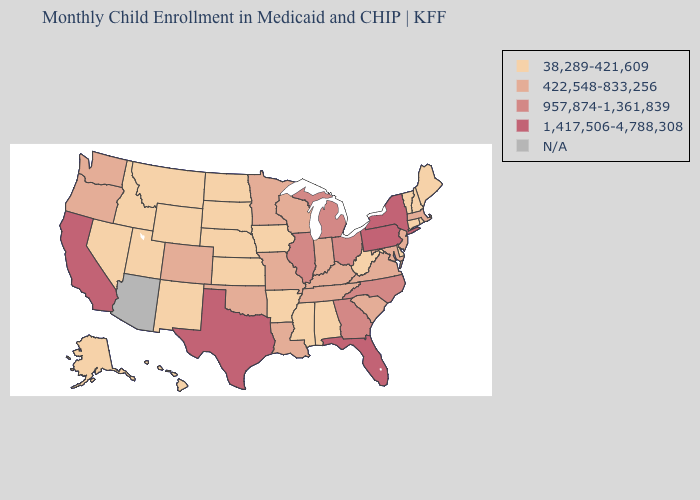Does the first symbol in the legend represent the smallest category?
Answer briefly. Yes. What is the lowest value in states that border Alabama?
Be succinct. 38,289-421,609. Which states have the lowest value in the South?
Concise answer only. Alabama, Arkansas, Delaware, Mississippi, West Virginia. Name the states that have a value in the range 422,548-833,256?
Be succinct. Colorado, Indiana, Kentucky, Louisiana, Maryland, Massachusetts, Minnesota, Missouri, New Jersey, Oklahoma, Oregon, South Carolina, Tennessee, Virginia, Washington, Wisconsin. Name the states that have a value in the range 1,417,506-4,788,308?
Concise answer only. California, Florida, New York, Pennsylvania, Texas. Does the first symbol in the legend represent the smallest category?
Concise answer only. Yes. Does California have the highest value in the USA?
Concise answer only. Yes. What is the value of Vermont?
Concise answer only. 38,289-421,609. What is the value of Vermont?
Write a very short answer. 38,289-421,609. Does California have the lowest value in the USA?
Answer briefly. No. Which states hav the highest value in the Northeast?
Keep it brief. New York, Pennsylvania. Does the first symbol in the legend represent the smallest category?
Keep it brief. Yes. What is the value of Pennsylvania?
Write a very short answer. 1,417,506-4,788,308. Which states have the lowest value in the USA?
Answer briefly. Alabama, Alaska, Arkansas, Connecticut, Delaware, Hawaii, Idaho, Iowa, Kansas, Maine, Mississippi, Montana, Nebraska, Nevada, New Hampshire, New Mexico, North Dakota, Rhode Island, South Dakota, Utah, Vermont, West Virginia, Wyoming. 